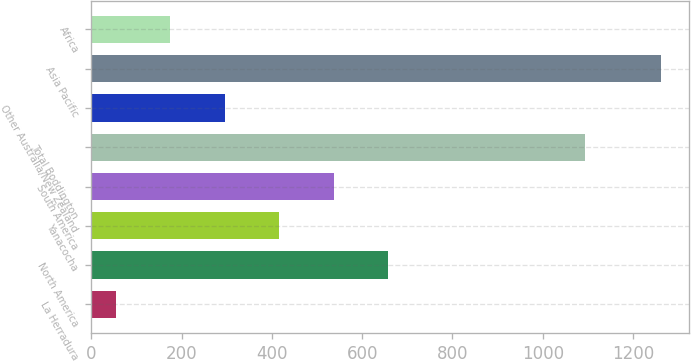Convert chart. <chart><loc_0><loc_0><loc_500><loc_500><bar_chart><fcel>La Herradura<fcel>North America<fcel>Yanacocha<fcel>South America<fcel>Total Boddington<fcel>Other Australia/New Zealand<fcel>Asia Pacific<fcel>Africa<nl><fcel>54<fcel>658<fcel>416.4<fcel>537.2<fcel>1093<fcel>295.6<fcel>1262<fcel>174.8<nl></chart> 